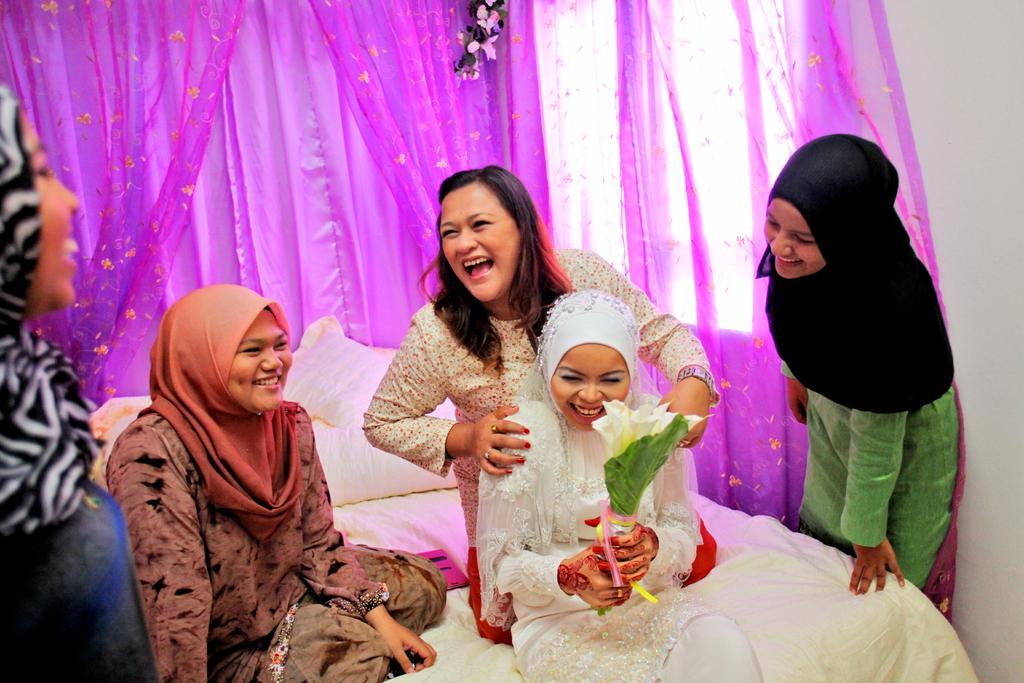How would you summarize this image in a sentence or two? In this image there are group of people some of them are wearing scarf and smiling, and they are sitting on a bed. On the bed there is blanket and pillow, and in the background there is a curtain, flowers, window and wall. 